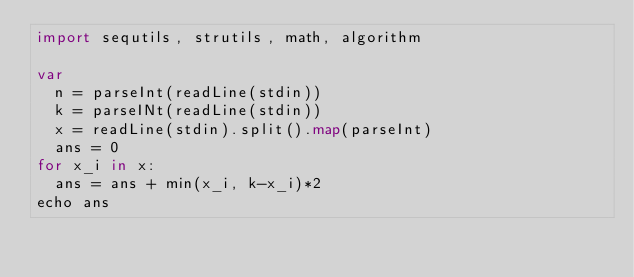<code> <loc_0><loc_0><loc_500><loc_500><_Nim_>import sequtils, strutils, math, algorithm

var
  n = parseInt(readLine(stdin))
  k = parseINt(readLine(stdin))
  x = readLine(stdin).split().map(parseInt)
  ans = 0
for x_i in x:
  ans = ans + min(x_i, k-x_i)*2
echo ans</code> 